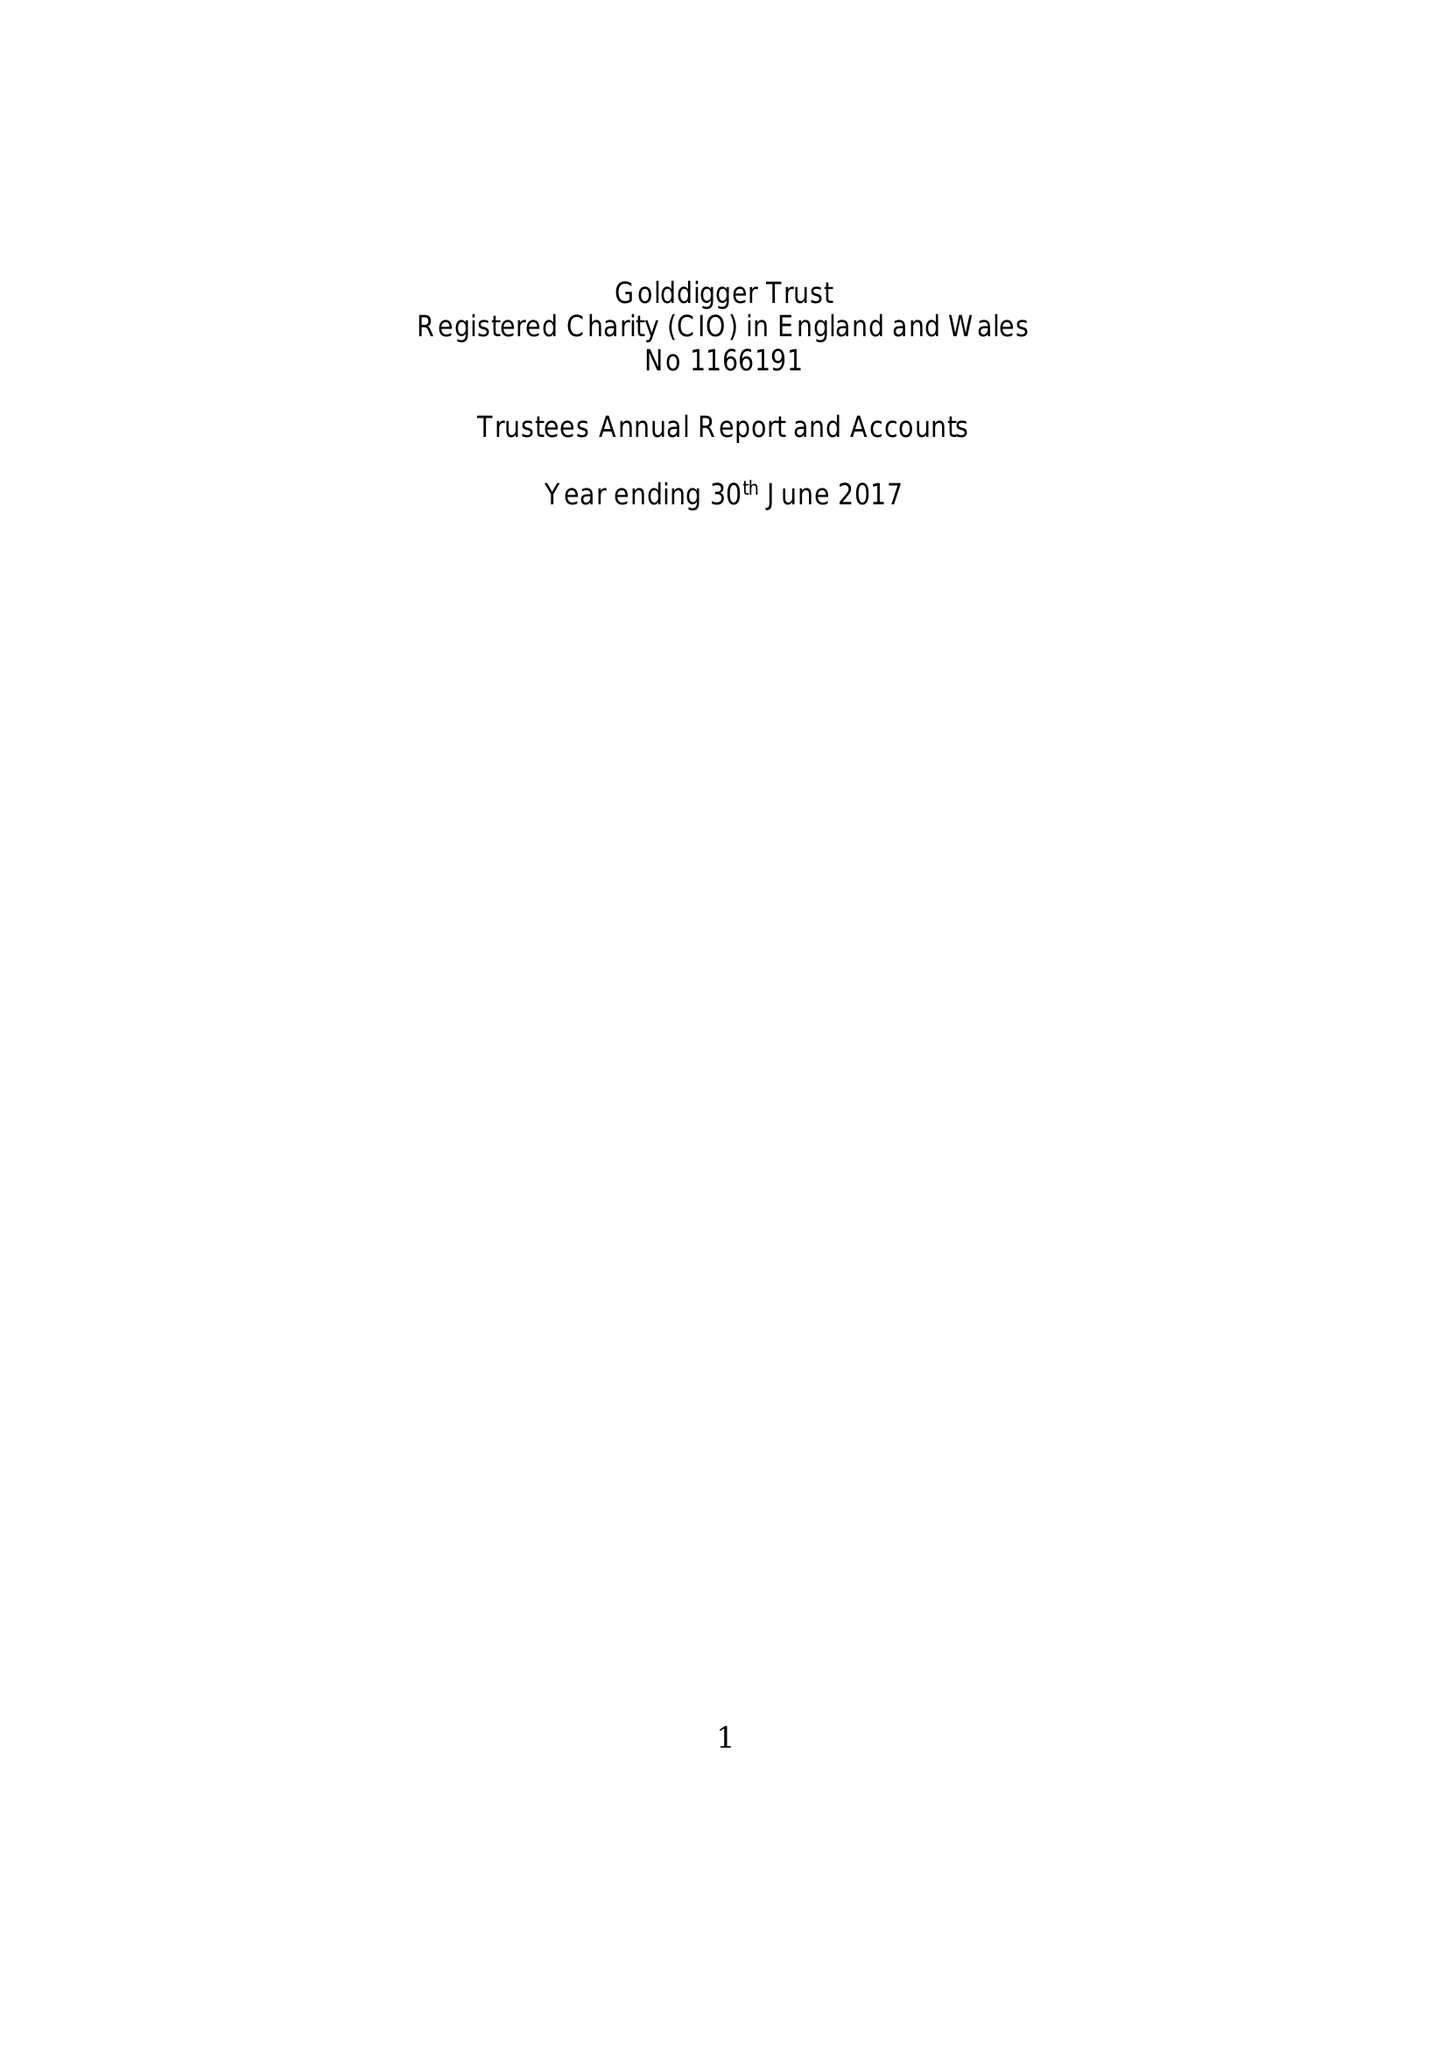What is the value for the charity_name?
Answer the question using a single word or phrase. Golddigger Trust 